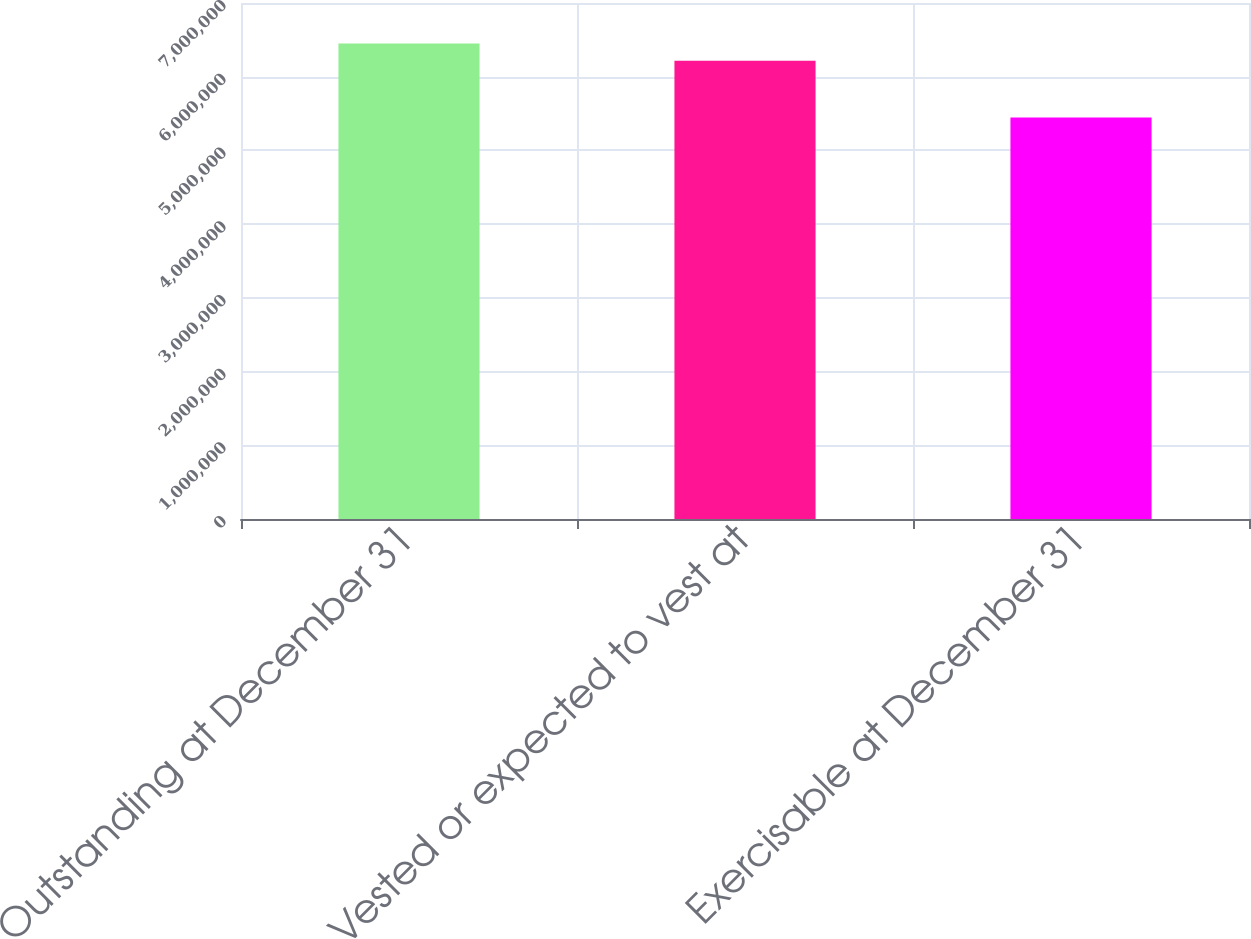<chart> <loc_0><loc_0><loc_500><loc_500><bar_chart><fcel>Outstanding at December 31<fcel>Vested or expected to vest at<fcel>Exercisable at December 31<nl><fcel>6.45074e+06<fcel>6.21713e+06<fcel>5.44586e+06<nl></chart> 